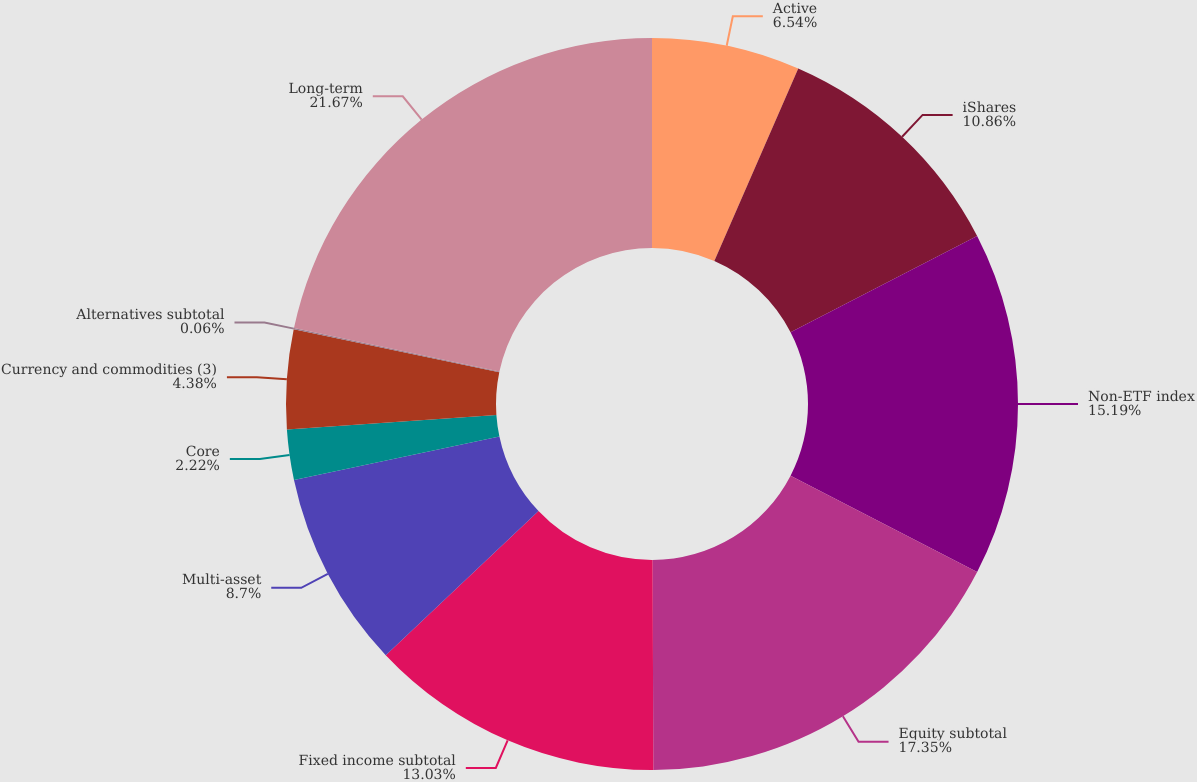<chart> <loc_0><loc_0><loc_500><loc_500><pie_chart><fcel>Active<fcel>iShares<fcel>Non-ETF index<fcel>Equity subtotal<fcel>Fixed income subtotal<fcel>Multi-asset<fcel>Core<fcel>Currency and commodities (3)<fcel>Alternatives subtotal<fcel>Long-term<nl><fcel>6.54%<fcel>10.86%<fcel>15.18%<fcel>17.34%<fcel>13.02%<fcel>8.7%<fcel>2.22%<fcel>4.38%<fcel>0.06%<fcel>21.66%<nl></chart> 